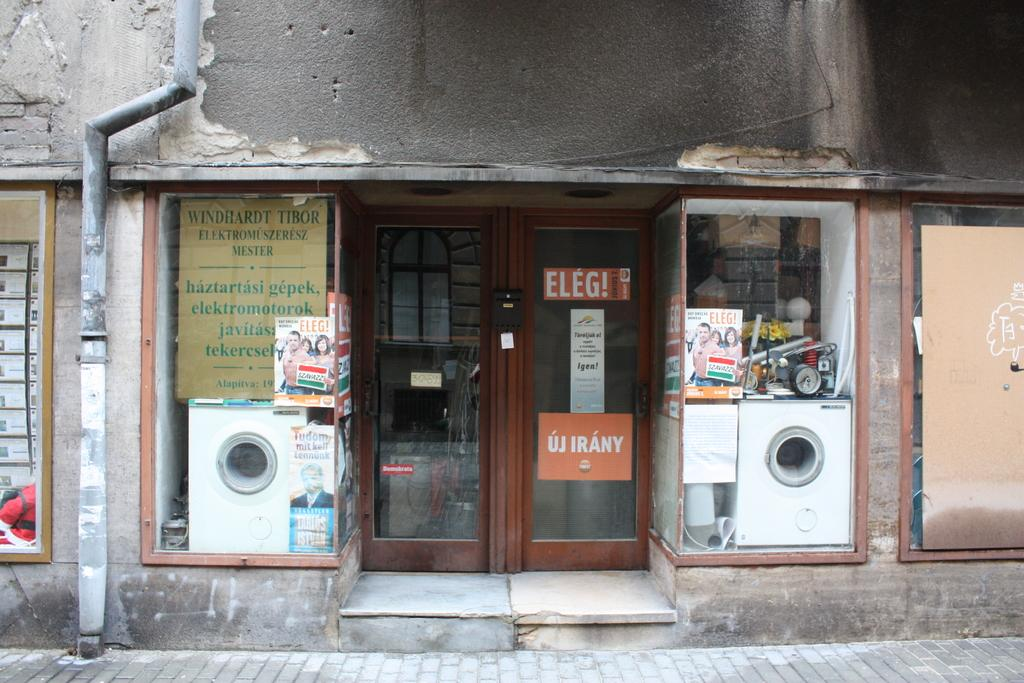What type of structure is present in the image? There is a building in the image. Can you describe any specific features of the building? There is a door in the image, which is a feature of the building. What else can be seen in the image besides the building? There is a pipe, a footpath, a poster, and various objects visible in the image. How many trucks are parked on the footpath in the image? There are no trucks present in the image; only a building, door, pipe, footpath, poster, and various objects can be seen. 